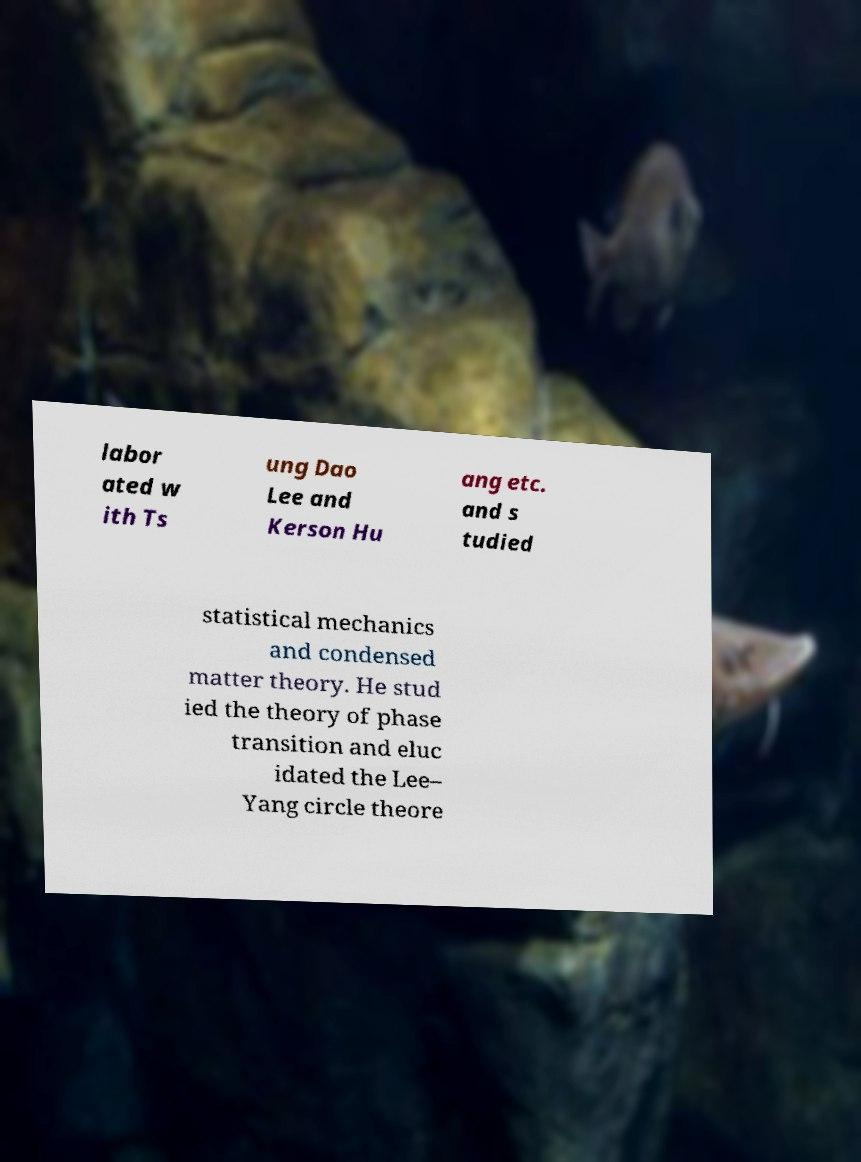I need the written content from this picture converted into text. Can you do that? labor ated w ith Ts ung Dao Lee and Kerson Hu ang etc. and s tudied statistical mechanics and condensed matter theory. He stud ied the theory of phase transition and eluc idated the Lee– Yang circle theore 